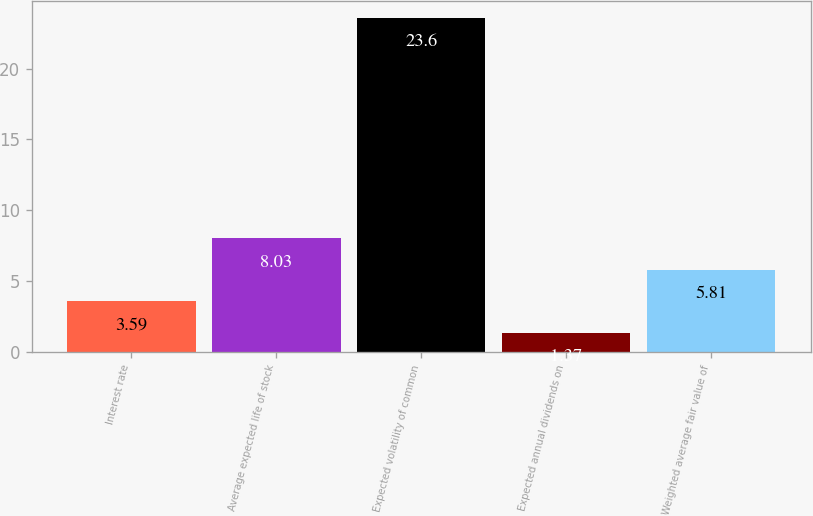<chart> <loc_0><loc_0><loc_500><loc_500><bar_chart><fcel>Interest rate<fcel>Average expected life of stock<fcel>Expected volatility of common<fcel>Expected annual dividends on<fcel>Weighted average fair value of<nl><fcel>3.59<fcel>8.03<fcel>23.6<fcel>1.37<fcel>5.81<nl></chart> 